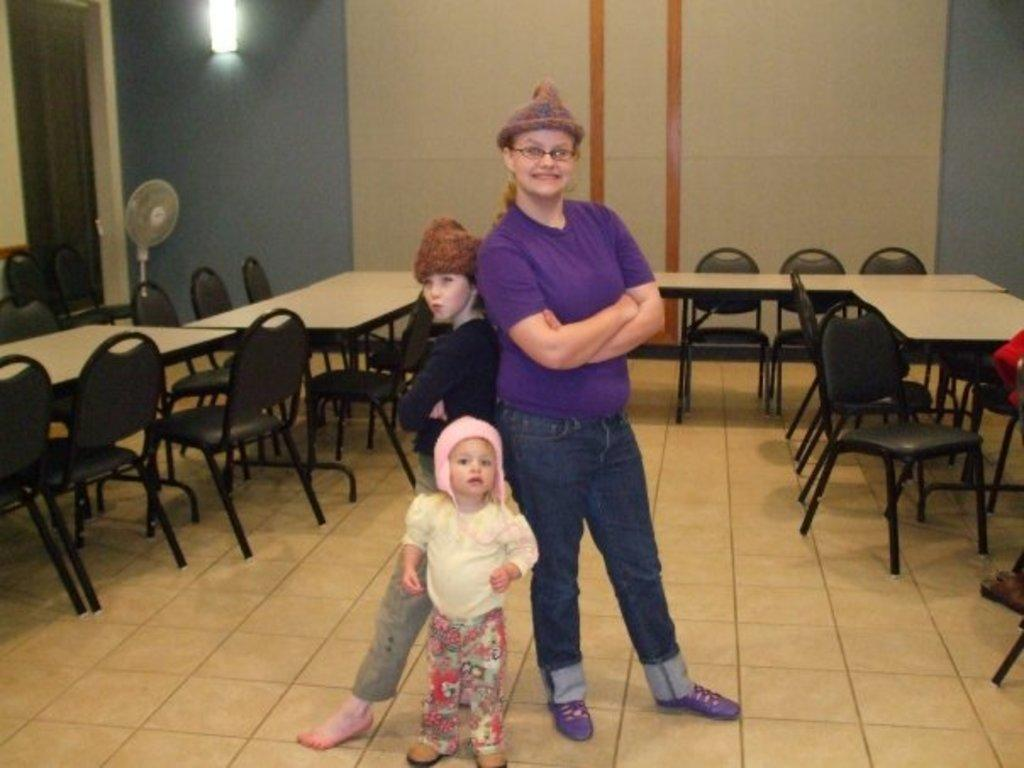How many people are in the image? There are three persons standing together in the image. What type of furniture is present in the image? There are chairs and tables in the image. Where is the light source located in the image? The light is at the top of the image. What type of hat is the person on the left wearing in the image? There is no hat visible on any of the persons in the image. How many mice can be seen running around on the tables in the image? There are no mice present in the image; only the three persons, chairs, and tables are visible. 